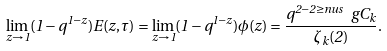Convert formula to latex. <formula><loc_0><loc_0><loc_500><loc_500>\lim _ { z \to 1 } ( 1 - q ^ { 1 - z } ) E ( z , \tau ) = \lim _ { z \to 1 } ( 1 - q ^ { 1 - z } ) \phi ( z ) = \frac { q ^ { 2 - 2 \geq n u s } \ g C _ { k } } { \zeta _ { k } ( 2 ) } .</formula> 